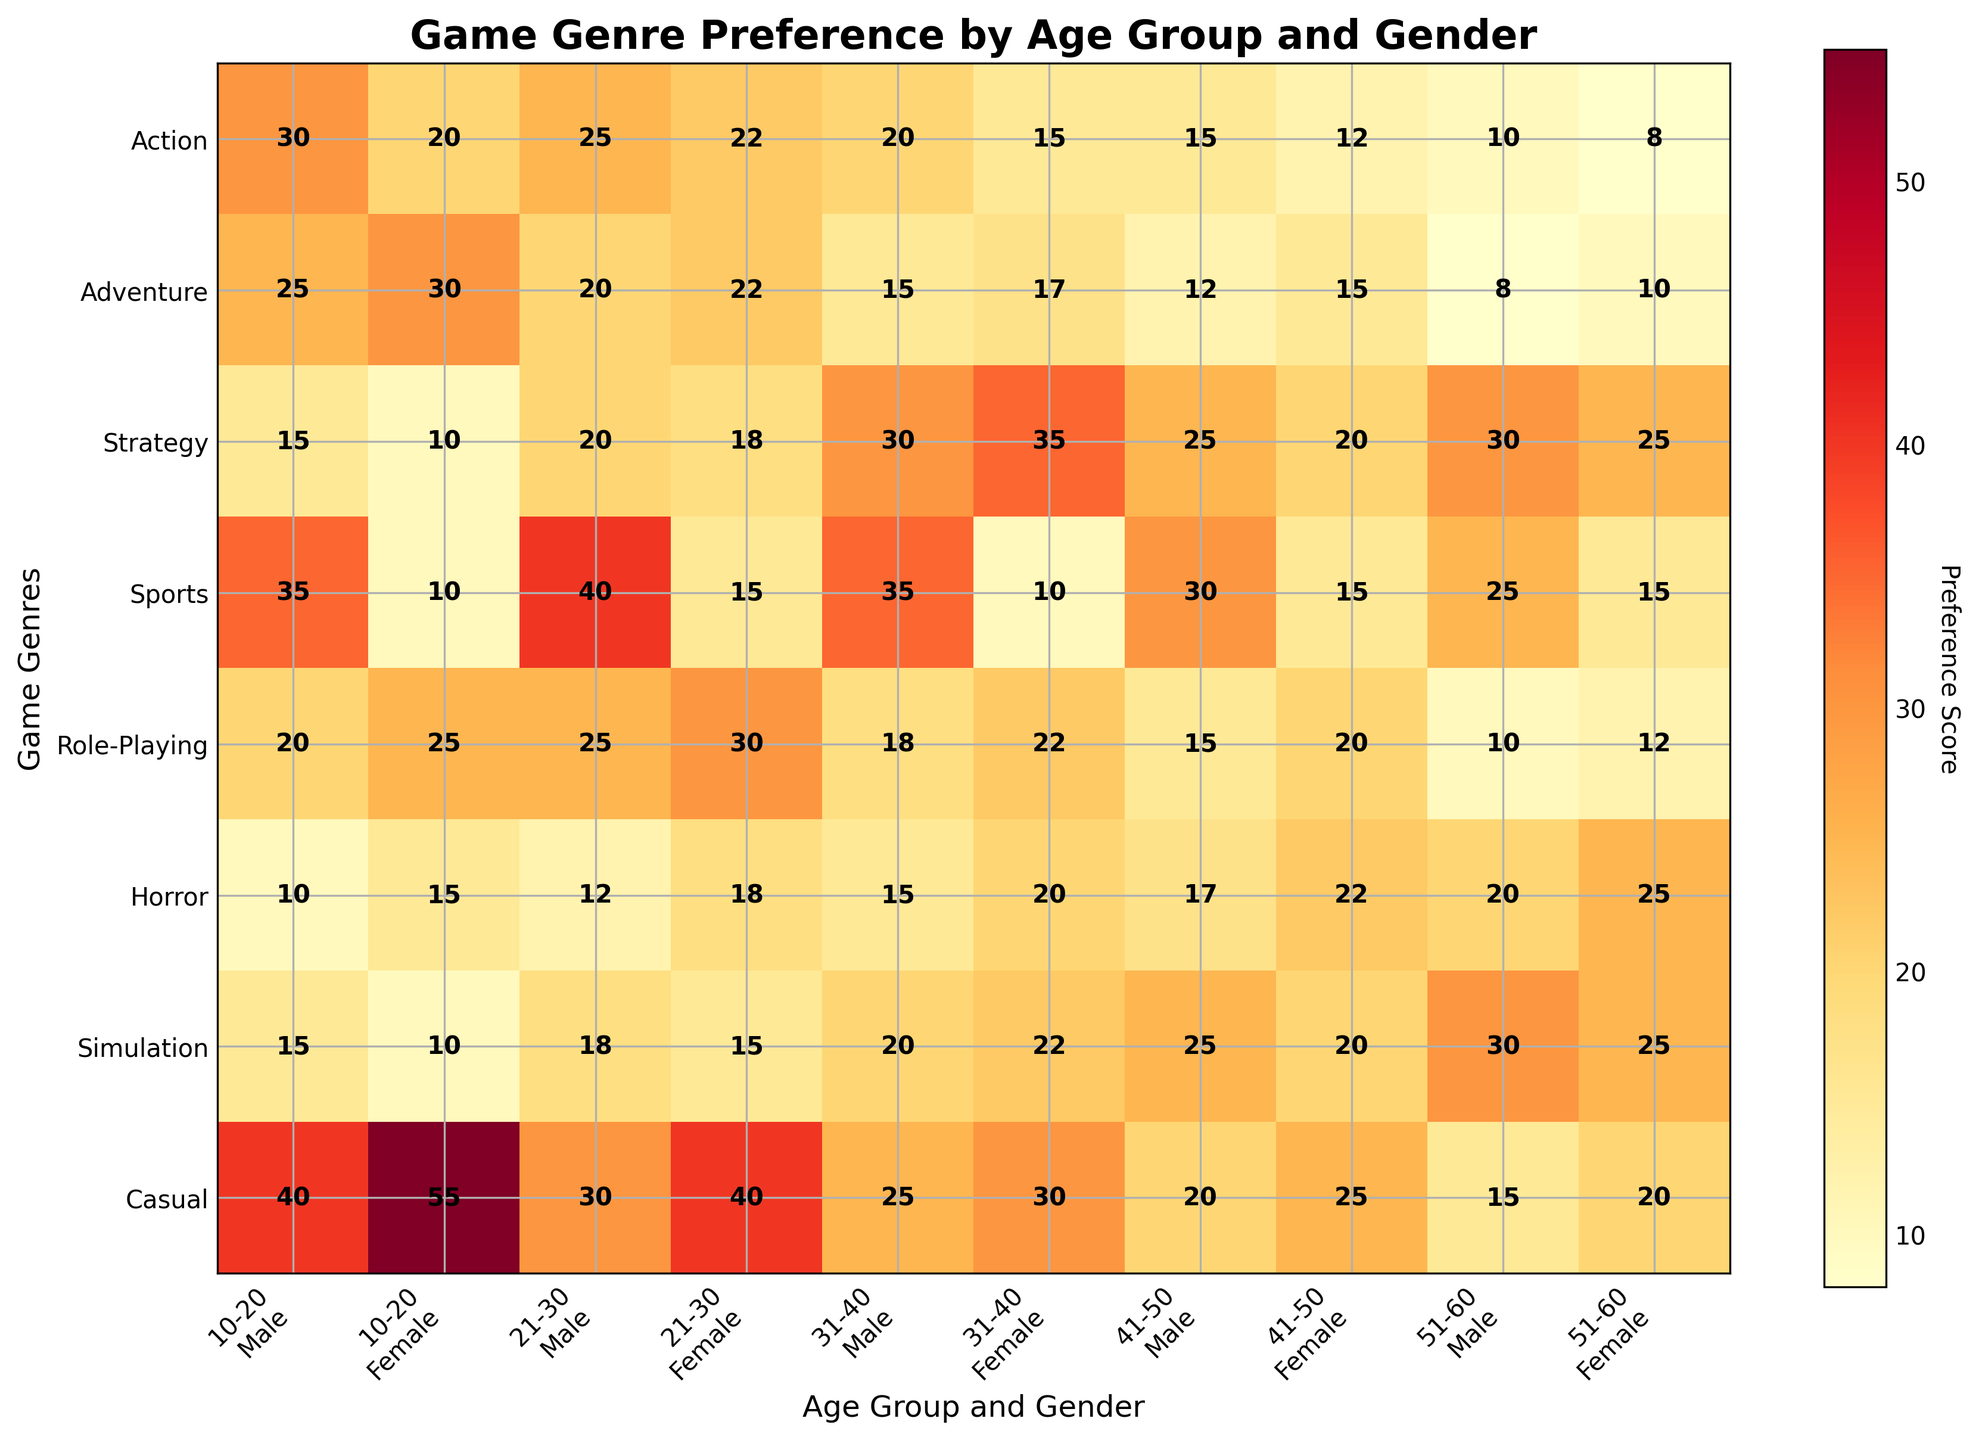What is the title of the heatmap? Look at the top of the heatmap where the title is usually placed. The title should be descriptive and explain what the heatmap represents.
Answer: Game Genre Preference by Age Group and Gender Which age group and gender has the highest preference score for the Casual genre? Locate the row for the Casual genre and identify the highest value in that row. Then refer to the corresponding column label to find the age group and gender.
Answer: 10-20 Female What is the difference in preference scores for the Sports genre between 31-40 males and 41-50 males? Find the values in the Sports genre row corresponding to 31-40 males and 41-50 males, then subtract the latter from the former.
Answer: 5 How do the preferences for the Horror genre compare between males and females aged 21-30? Find the values for the Horror genre row corresponding to 21-30 males and 21-30 females, then compare these two values.
Answer: Females have a higher preference by 6 points Which genre has the highest preference score among 21-30 females? Locate the columns for 21-30 females and identify the highest value within all the genres. Then refer to the genre label on the y-axis.
Answer: Role-Playing Calculate the average preference score for the Adventure genre across all age groups for females. Locate the Adventure row and extract all the values corresponding to females. Add these values and divide by the number of age groups.
Answer: (30 + 22 + 17 + 15 + 10) / 5 = 18.8 Which age group and gender combination shows the lowest preference for the Horror genre? Locate the row for the Horror genre and identify the lowest value in that row. Then refer to the corresponding column label to find the age group and gender.
Answer: 10-20 Male Compare the preference scores of the Role-Playing genre for females aged 10-20 and males aged 31-40. Which group shows a higher preference? Find the values in the Role-Playing genre row corresponding to 10-20 females and 31-40 males, then compare these two values.
Answer: 10-20 Females Which genre has the most balanced preference scores across all age groups and genders? Look for a genre row where the values vary the least across all columns. This might be identified by inspecting the spread of the data visually or calculating the variance.
Answer: Simulation Which age group and gender show a higher preference for Strategy games compared to Action games? Compare the scores for Strategy and Action games within each age and gender group. Identify which specific age group and gender has a higher Strategy score than Action score.
Answer: 31-40 Female 